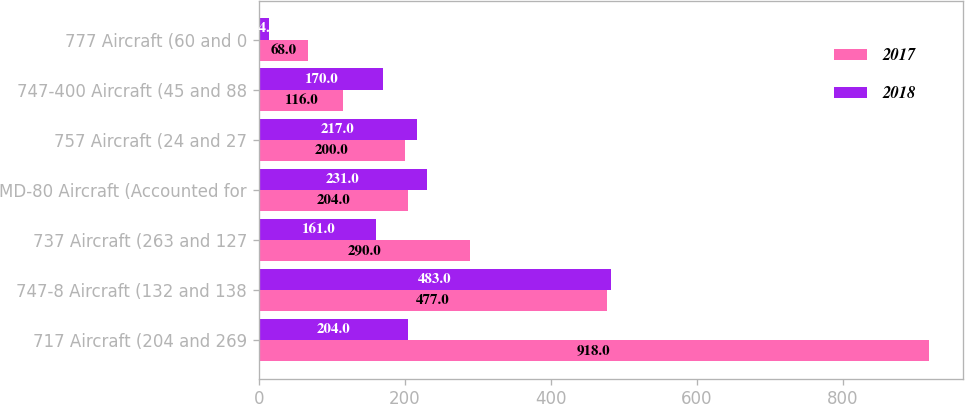Convert chart. <chart><loc_0><loc_0><loc_500><loc_500><stacked_bar_chart><ecel><fcel>717 Aircraft (204 and 269<fcel>747-8 Aircraft (132 and 138<fcel>737 Aircraft (263 and 127<fcel>MD-80 Aircraft (Accounted for<fcel>757 Aircraft (24 and 27<fcel>747-400 Aircraft (45 and 88<fcel>777 Aircraft (60 and 0<nl><fcel>2017<fcel>918<fcel>477<fcel>290<fcel>204<fcel>200<fcel>116<fcel>68<nl><fcel>2018<fcel>204<fcel>483<fcel>161<fcel>231<fcel>217<fcel>170<fcel>14<nl></chart> 